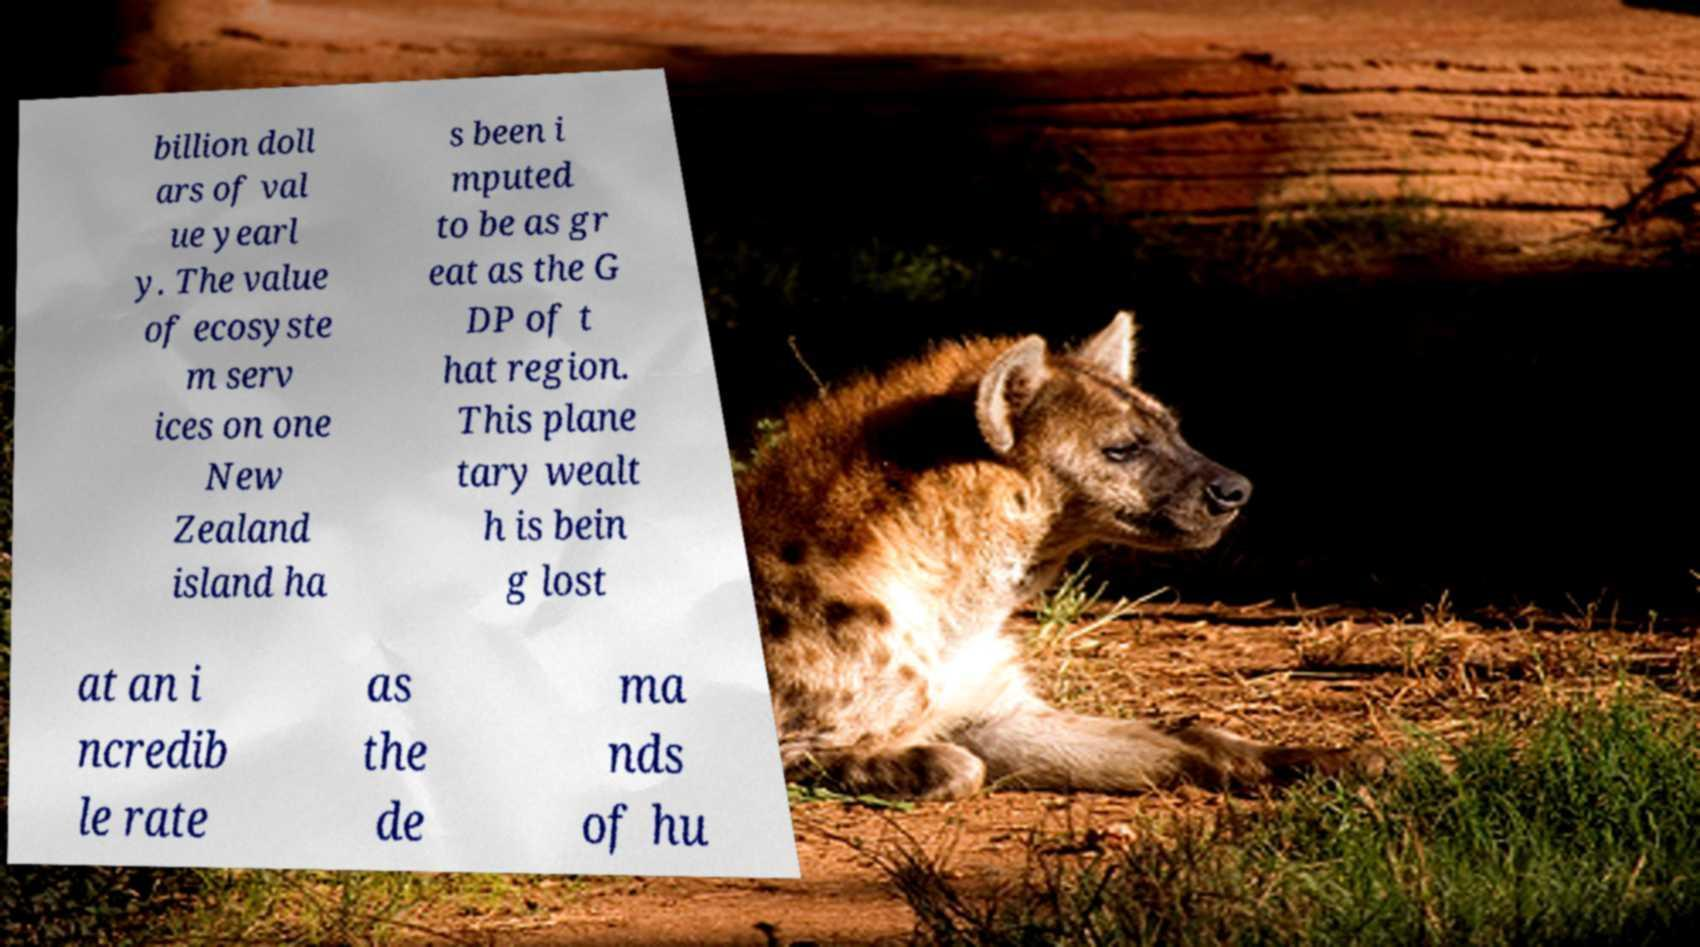Please read and relay the text visible in this image. What does it say? billion doll ars of val ue yearl y. The value of ecosyste m serv ices on one New Zealand island ha s been i mputed to be as gr eat as the G DP of t hat region. This plane tary wealt h is bein g lost at an i ncredib le rate as the de ma nds of hu 